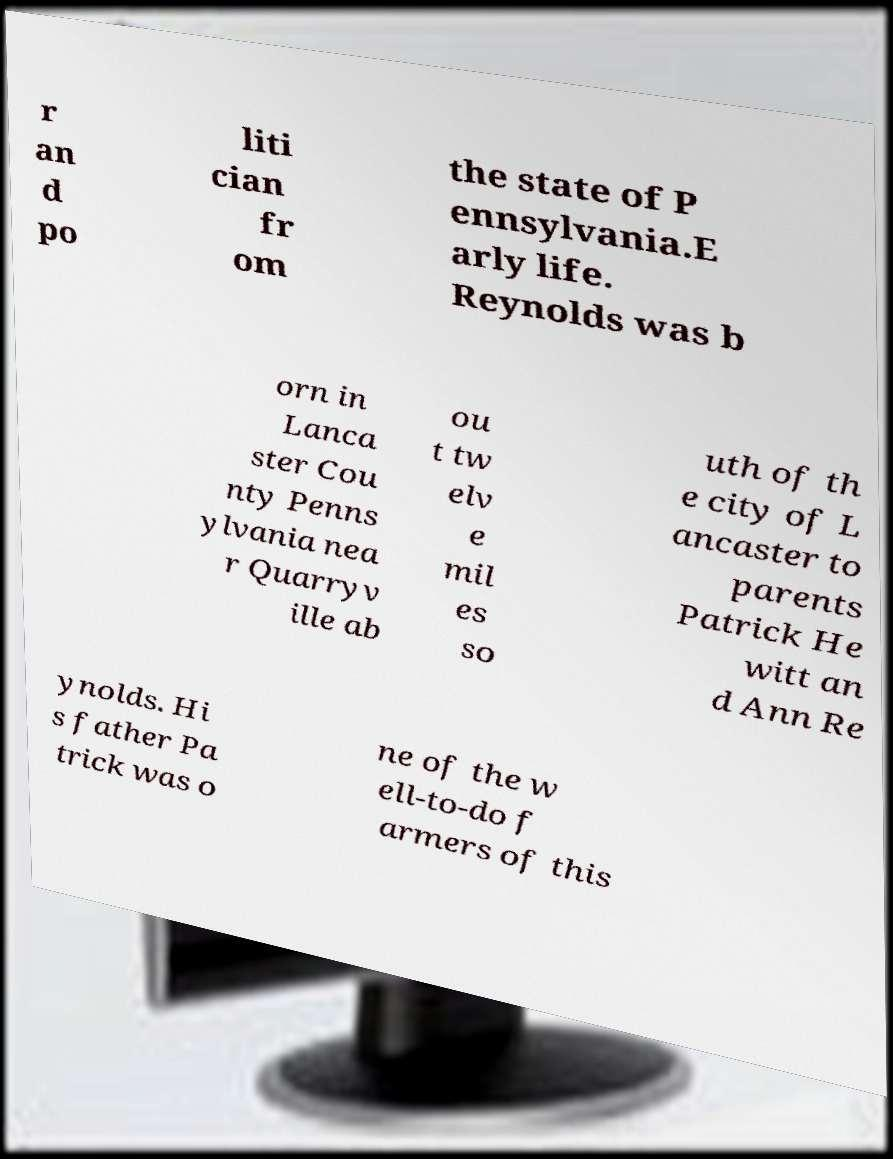Can you read and provide the text displayed in the image?This photo seems to have some interesting text. Can you extract and type it out for me? r an d po liti cian fr om the state of P ennsylvania.E arly life. Reynolds was b orn in Lanca ster Cou nty Penns ylvania nea r Quarryv ille ab ou t tw elv e mil es so uth of th e city of L ancaster to parents Patrick He witt an d Ann Re ynolds. Hi s father Pa trick was o ne of the w ell-to-do f armers of this 